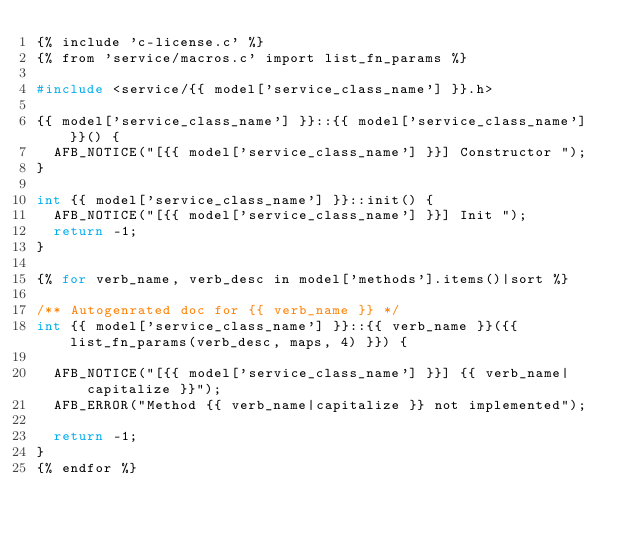<code> <loc_0><loc_0><loc_500><loc_500><_C_>{% include 'c-license.c' %}
{% from 'service/macros.c' import list_fn_params %}

#include <service/{{ model['service_class_name'] }}.h>

{{ model['service_class_name'] }}::{{ model['service_class_name'] }}() {
  AFB_NOTICE("[{{ model['service_class_name'] }}] Constructor ");
}

int {{ model['service_class_name'] }}::init() {
  AFB_NOTICE("[{{ model['service_class_name'] }}] Init ");
  return -1;
}

{% for verb_name, verb_desc in model['methods'].items()|sort %}

/** Autogenrated doc for {{ verb_name }} */
int {{ model['service_class_name'] }}::{{ verb_name }}({{ list_fn_params(verb_desc, maps, 4) }}) {

  AFB_NOTICE("[{{ model['service_class_name'] }}] {{ verb_name|capitalize }}");
  AFB_ERROR("Method {{ verb_name|capitalize }} not implemented");

  return -1;
}
{% endfor %}
</code> 